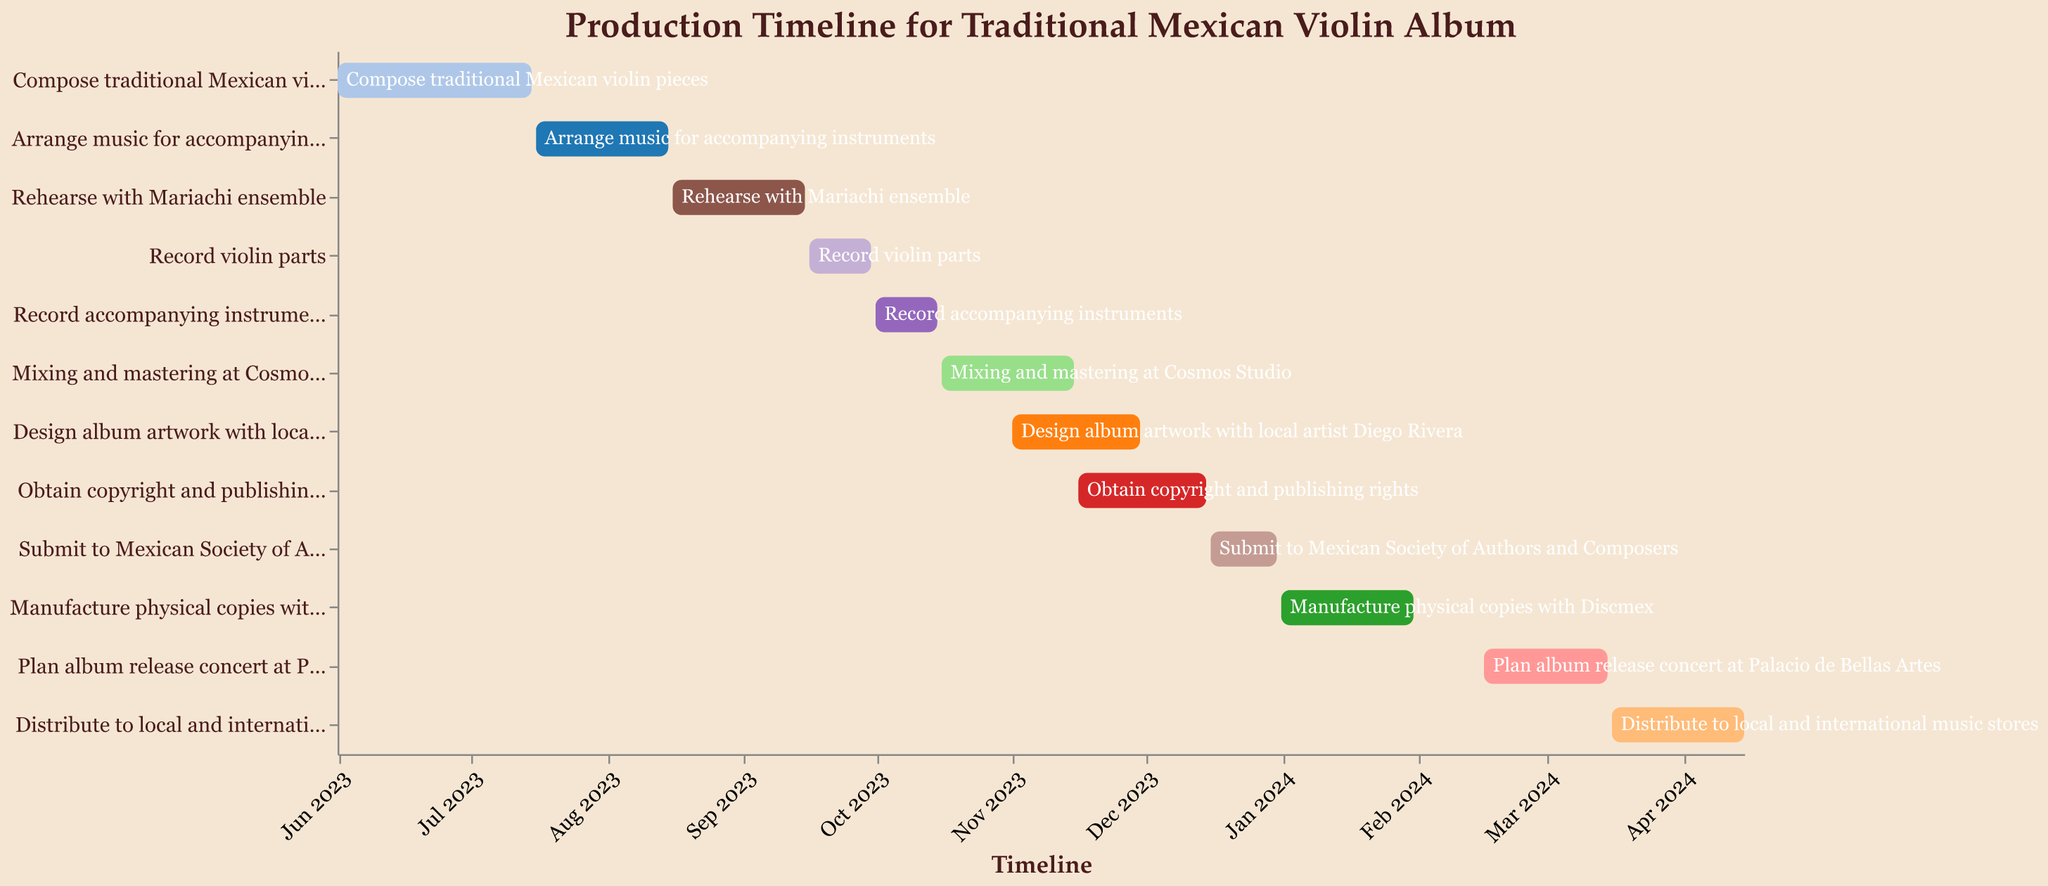What is the title of the chart? The title of the chart is displayed at the top of the figure in a prominent manner. The title is "Production Timeline for Traditional Mexican Violin Album".
Answer: Production Timeline for Traditional Mexican Violin Album What are the start and end dates for composing traditional Mexican violin pieces? The data provided shows that the task "Compose traditional Mexican violin pieces" starts on "2023-06-01" and ends on "2023-07-15". These dates are visualized on the timeline axis.
Answer: June 1, 2023 - July 15, 2023 Which task ends first on the timeline? By looking at the earliest end date among all tasks, "Compose traditional Mexican violin pieces" ends first on "2023-07-15".
Answer: Compose traditional Mexican violin pieces How many tasks are scheduled to take place in November 2023? From the chart, we see three tasks overlapping in November 2023: "Mixing and mastering at Cosmos Studio", "Design album artwork with local artist Diego Rivera", and "Obtain copyright and publishing rights".
Answer: 3 What is the duration of the task "Manufacture physical copies with Discmex"? The start date is "2024-01-01" and the end date is "2024-01-31". The duration is calculated by counting the days from start to end, inclusive.
Answer: 31 days Which two tasks overlap the most in October 2023? By examining the overlapping periods in October, both "Record accompanying instruments" (2023-10-01 to 2023-10-15) and "Mixing and mastering at Cosmos Studio" (2023-10-16 to 2023-11-15) show the maximum overlap within the month of October.
Answer: Record accompanying instruments and Mixing and mastering at Cosmos Studio When does the task "Plan album release concert at Palacio de Bellas Artes" start and finish? Looking at the timeline for the task "Plan album release concert at Palacio de Bellas Artes", it starts on "2024-02-16" and finishes on "2024-03-15".
Answer: February 16, 2024 - March 15, 2024 How long is the entire production process, from the first to the last task? The first task "Compose traditional Mexican violin pieces" starts on "2023-06-01" and the last task "Distribute to local and international music stores" ends on "2024-04-15". The production span can be calculated from the start date of the first task to the end date of the last task.
Answer: About 10 and a half months What task follows immediately after recording violin parts? The task that begins right after "Record violin parts" is "Record accompanying instruments", which starts on "2023-10-01".
Answer: Record accompanying instruments Which task has the shortest duration, and how many days is it? By comparing the durations of all tasks, "Record violin parts" has the shortest span, lasting from "2023-09-16" to "2023-09-30". The duration is calculated by counting the days within this range.
Answer: Record violin parts, 15 days 